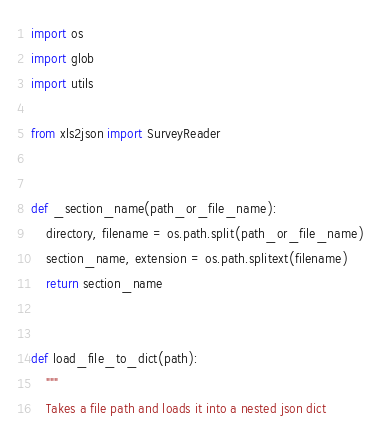<code> <loc_0><loc_0><loc_500><loc_500><_Python_>import os
import glob
import utils

from xls2json import SurveyReader


def _section_name(path_or_file_name):
    directory, filename = os.path.split(path_or_file_name)
    section_name, extension = os.path.splitext(filename)
    return section_name


def load_file_to_dict(path):
    """
    Takes a file path and loads it into a nested json dict</code> 